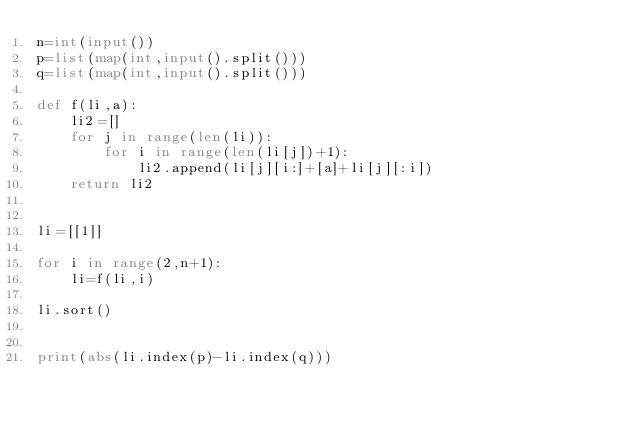<code> <loc_0><loc_0><loc_500><loc_500><_Python_>n=int(input())
p=list(map(int,input().split()))
q=list(map(int,input().split()))

def f(li,a):
    li2=[]
    for j in range(len(li)):
        for i in range(len(li[j])+1):
            li2.append(li[j][i:]+[a]+li[j][:i])
    return li2


li=[[1]]

for i in range(2,n+1):
    li=f(li,i)
    
li.sort()


print(abs(li.index(p)-li.index(q)))</code> 